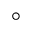Convert formula to latex. <formula><loc_0><loc_0><loc_500><loc_500>^ { \circ }</formula> 